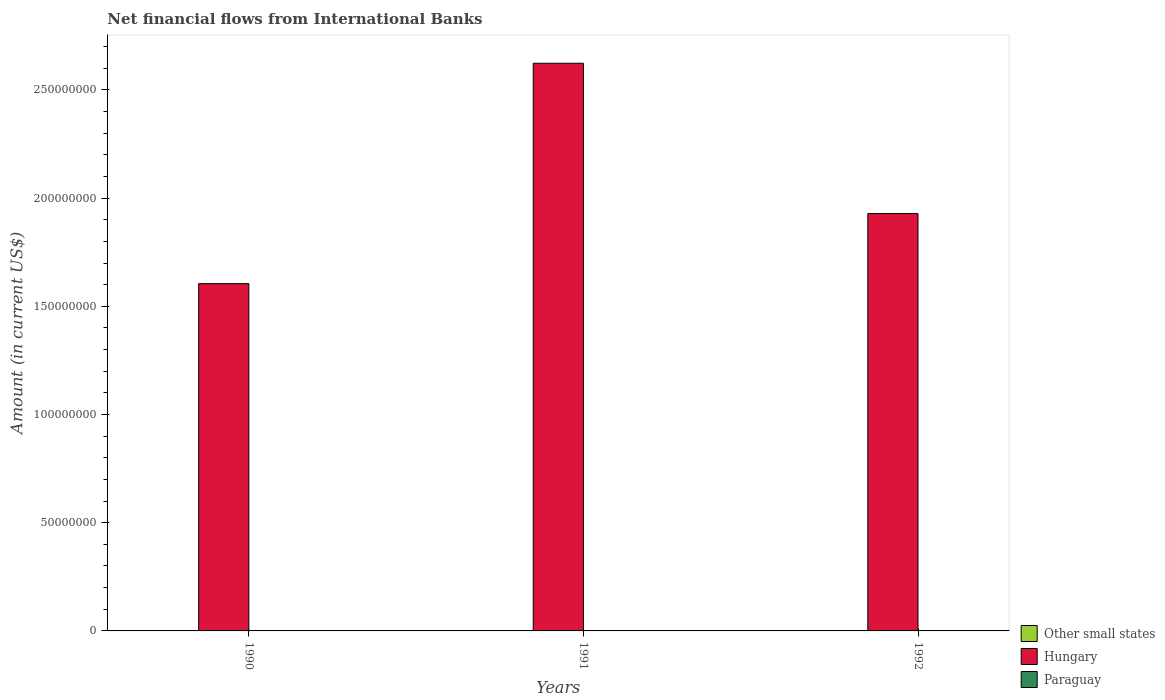Are the number of bars per tick equal to the number of legend labels?
Provide a succinct answer. No. How many bars are there on the 3rd tick from the right?
Offer a terse response. 1. What is the label of the 3rd group of bars from the left?
Your answer should be very brief. 1992. In how many cases, is the number of bars for a given year not equal to the number of legend labels?
Offer a very short reply. 3. What is the net financial aid flows in Other small states in 1992?
Offer a very short reply. 0. Across all years, what is the maximum net financial aid flows in Hungary?
Ensure brevity in your answer.  2.62e+08. In which year was the net financial aid flows in Hungary maximum?
Your response must be concise. 1991. What is the total net financial aid flows in Other small states in the graph?
Provide a succinct answer. 0. What is the difference between the net financial aid flows in Hungary in 1990 and that in 1992?
Offer a very short reply. -3.24e+07. What is the difference between the net financial aid flows in Paraguay in 1992 and the net financial aid flows in Hungary in 1991?
Your response must be concise. -2.62e+08. What is the ratio of the net financial aid flows in Hungary in 1990 to that in 1992?
Your answer should be very brief. 0.83. What is the difference between the highest and the second highest net financial aid flows in Hungary?
Give a very brief answer. 6.94e+07. What is the difference between the highest and the lowest net financial aid flows in Hungary?
Offer a very short reply. 1.02e+08. In how many years, is the net financial aid flows in Paraguay greater than the average net financial aid flows in Paraguay taken over all years?
Offer a terse response. 0. Is the sum of the net financial aid flows in Hungary in 1990 and 1992 greater than the maximum net financial aid flows in Other small states across all years?
Your answer should be compact. Yes. Is it the case that in every year, the sum of the net financial aid flows in Other small states and net financial aid flows in Hungary is greater than the net financial aid flows in Paraguay?
Offer a terse response. Yes. Are all the bars in the graph horizontal?
Offer a terse response. No. How many years are there in the graph?
Give a very brief answer. 3. What is the difference between two consecutive major ticks on the Y-axis?
Your answer should be compact. 5.00e+07. Are the values on the major ticks of Y-axis written in scientific E-notation?
Your answer should be very brief. No. Does the graph contain any zero values?
Ensure brevity in your answer.  Yes. Where does the legend appear in the graph?
Give a very brief answer. Bottom right. What is the title of the graph?
Offer a very short reply. Net financial flows from International Banks. Does "Zambia" appear as one of the legend labels in the graph?
Provide a short and direct response. No. What is the label or title of the X-axis?
Offer a terse response. Years. What is the Amount (in current US$) in Other small states in 1990?
Make the answer very short. 0. What is the Amount (in current US$) in Hungary in 1990?
Offer a very short reply. 1.60e+08. What is the Amount (in current US$) in Other small states in 1991?
Make the answer very short. 0. What is the Amount (in current US$) in Hungary in 1991?
Your answer should be compact. 2.62e+08. What is the Amount (in current US$) in Other small states in 1992?
Give a very brief answer. 0. What is the Amount (in current US$) of Hungary in 1992?
Your response must be concise. 1.93e+08. Across all years, what is the maximum Amount (in current US$) in Hungary?
Ensure brevity in your answer.  2.62e+08. Across all years, what is the minimum Amount (in current US$) in Hungary?
Your response must be concise. 1.60e+08. What is the total Amount (in current US$) of Hungary in the graph?
Provide a short and direct response. 6.16e+08. What is the difference between the Amount (in current US$) in Hungary in 1990 and that in 1991?
Provide a succinct answer. -1.02e+08. What is the difference between the Amount (in current US$) in Hungary in 1990 and that in 1992?
Your answer should be very brief. -3.24e+07. What is the difference between the Amount (in current US$) of Hungary in 1991 and that in 1992?
Give a very brief answer. 6.94e+07. What is the average Amount (in current US$) of Other small states per year?
Your answer should be compact. 0. What is the average Amount (in current US$) of Hungary per year?
Make the answer very short. 2.05e+08. What is the average Amount (in current US$) in Paraguay per year?
Make the answer very short. 0. What is the ratio of the Amount (in current US$) of Hungary in 1990 to that in 1991?
Keep it short and to the point. 0.61. What is the ratio of the Amount (in current US$) in Hungary in 1990 to that in 1992?
Your answer should be very brief. 0.83. What is the ratio of the Amount (in current US$) of Hungary in 1991 to that in 1992?
Ensure brevity in your answer.  1.36. What is the difference between the highest and the second highest Amount (in current US$) of Hungary?
Offer a very short reply. 6.94e+07. What is the difference between the highest and the lowest Amount (in current US$) in Hungary?
Offer a very short reply. 1.02e+08. 